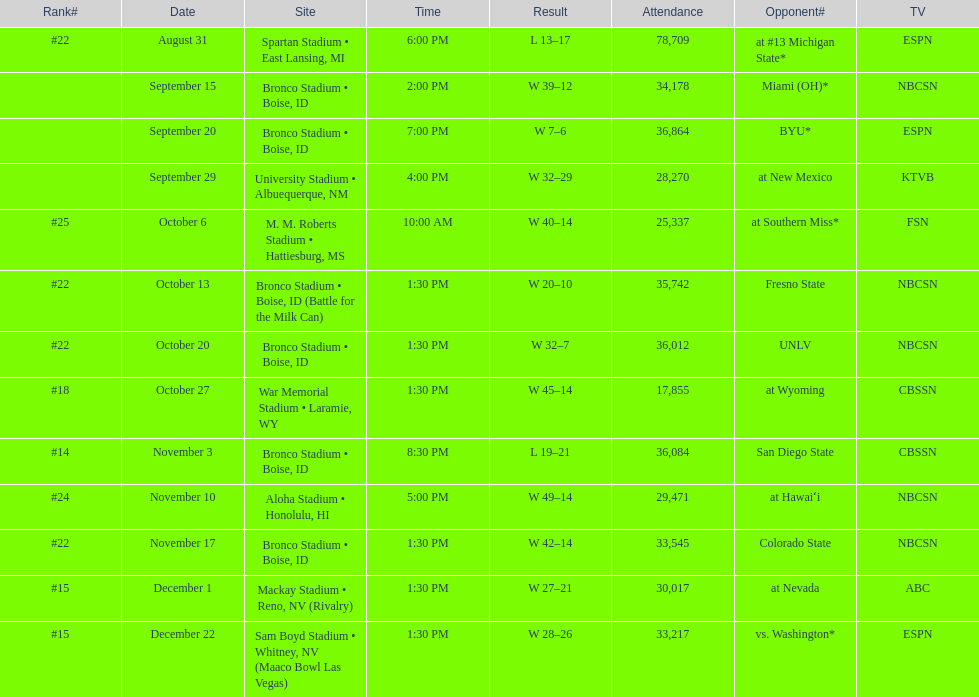What is the score difference for the game against michigan state? 4. 